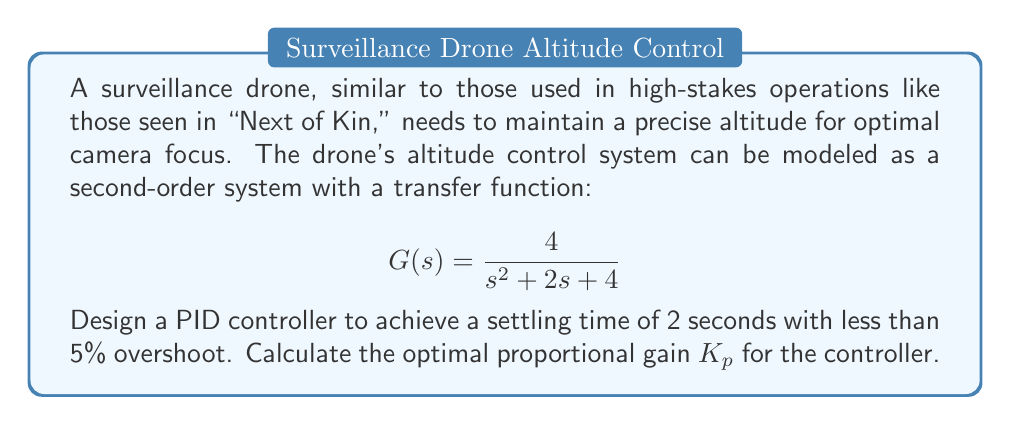Teach me how to tackle this problem. To design the PID controller, we'll follow these steps:

1) For a second-order system, the general form of the transfer function is:

   $$G(s) = \frac{\omega_n^2}{s^2 + 2\zeta\omega_n s + \omega_n^2}$$

   Comparing this to our given transfer function, we can see that $\omega_n^2 = 4$, so $\omega_n = 2$ rad/s.

2) To achieve less than 5% overshoot, we need a damping ratio $\zeta$ of about 0.69 or higher. Let's use $\zeta = 0.7$ for our calculations.

3) The settling time $t_s$ is related to $\zeta$ and $\omega_n$ by the formula:

   $$t_s \approx \frac{4}{\zeta\omega_n}$$

4) We want $t_s = 2$ seconds, so:

   $$2 = \frac{4}{0.7\omega_n}$$

   $$\omega_n = \frac{4}{1.4} \approx 2.86 \text{ rad/s}$$

5) The proportional gain $K_p$ can be calculated using:

   $$K_p = \frac{2\zeta\omega_n - 2}{4}$$

6) Substituting our values:

   $$K_p = \frac{2(0.7)(2.86) - 2}{4} = \frac{4.004 - 2}{4} = 0.501$$

Therefore, the optimal proportional gain $K_p$ for the PID controller is approximately 0.501.
Answer: $K_p \approx 0.501$ 